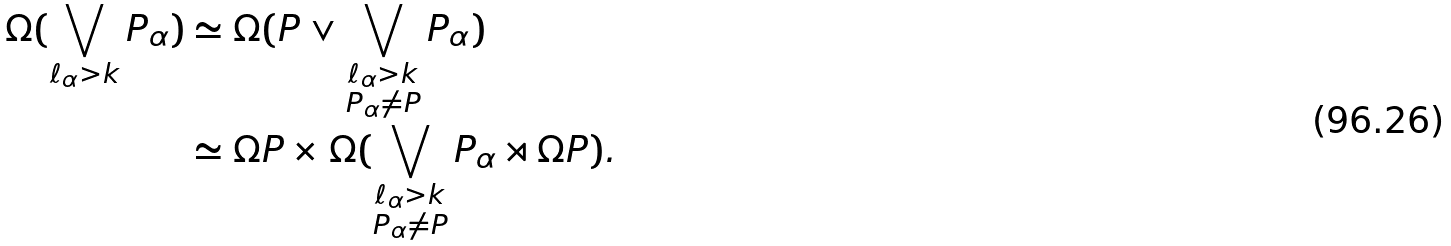<formula> <loc_0><loc_0><loc_500><loc_500>\Omega ( \bigvee _ { \ell _ { \alpha } > k } P _ { \alpha } ) & \simeq \Omega ( P \vee \bigvee _ { \substack { \ell _ { \alpha } > k \\ P _ { \alpha } \neq P } } P _ { \alpha } ) \\ & \simeq \Omega P \times \Omega ( \bigvee _ { \substack { \ell _ { \alpha } > k \\ P _ { \alpha } \neq P } } P _ { \alpha } \rtimes \Omega P ) .</formula> 